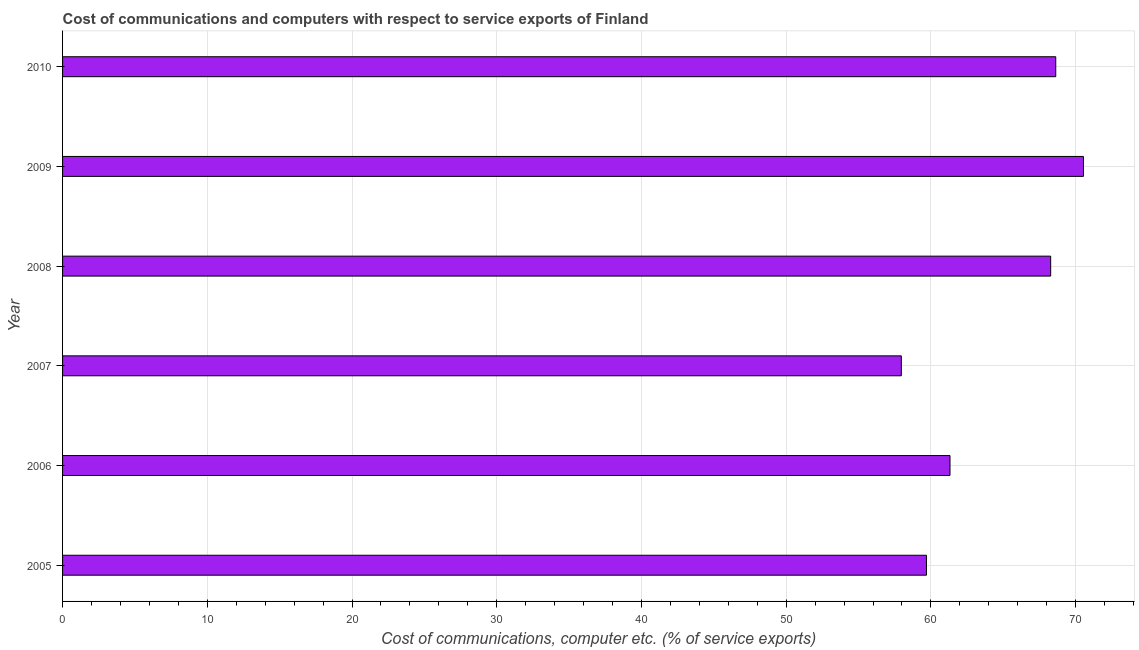Does the graph contain any zero values?
Ensure brevity in your answer.  No. What is the title of the graph?
Your answer should be very brief. Cost of communications and computers with respect to service exports of Finland. What is the label or title of the X-axis?
Make the answer very short. Cost of communications, computer etc. (% of service exports). What is the cost of communications and computer in 2009?
Keep it short and to the point. 70.54. Across all years, what is the maximum cost of communications and computer?
Offer a very short reply. 70.54. Across all years, what is the minimum cost of communications and computer?
Offer a very short reply. 57.95. In which year was the cost of communications and computer maximum?
Provide a succinct answer. 2009. In which year was the cost of communications and computer minimum?
Provide a succinct answer. 2007. What is the sum of the cost of communications and computer?
Provide a short and direct response. 386.4. What is the difference between the cost of communications and computer in 2007 and 2008?
Your answer should be very brief. -10.32. What is the average cost of communications and computer per year?
Ensure brevity in your answer.  64.4. What is the median cost of communications and computer?
Offer a very short reply. 64.8. Do a majority of the years between 2007 and 2005 (inclusive) have cost of communications and computer greater than 34 %?
Your response must be concise. Yes. What is the difference between the highest and the second highest cost of communications and computer?
Provide a succinct answer. 1.91. What is the difference between the highest and the lowest cost of communications and computer?
Provide a succinct answer. 12.58. In how many years, is the cost of communications and computer greater than the average cost of communications and computer taken over all years?
Offer a terse response. 3. How many bars are there?
Your response must be concise. 6. How many years are there in the graph?
Give a very brief answer. 6. What is the Cost of communications, computer etc. (% of service exports) in 2005?
Provide a succinct answer. 59.69. What is the Cost of communications, computer etc. (% of service exports) in 2006?
Your answer should be very brief. 61.32. What is the Cost of communications, computer etc. (% of service exports) of 2007?
Give a very brief answer. 57.95. What is the Cost of communications, computer etc. (% of service exports) in 2008?
Provide a succinct answer. 68.27. What is the Cost of communications, computer etc. (% of service exports) of 2009?
Your answer should be compact. 70.54. What is the Cost of communications, computer etc. (% of service exports) of 2010?
Keep it short and to the point. 68.62. What is the difference between the Cost of communications, computer etc. (% of service exports) in 2005 and 2006?
Provide a short and direct response. -1.63. What is the difference between the Cost of communications, computer etc. (% of service exports) in 2005 and 2007?
Ensure brevity in your answer.  1.74. What is the difference between the Cost of communications, computer etc. (% of service exports) in 2005 and 2008?
Give a very brief answer. -8.58. What is the difference between the Cost of communications, computer etc. (% of service exports) in 2005 and 2009?
Provide a short and direct response. -10.85. What is the difference between the Cost of communications, computer etc. (% of service exports) in 2005 and 2010?
Offer a very short reply. -8.93. What is the difference between the Cost of communications, computer etc. (% of service exports) in 2006 and 2007?
Provide a succinct answer. 3.36. What is the difference between the Cost of communications, computer etc. (% of service exports) in 2006 and 2008?
Your answer should be compact. -6.96. What is the difference between the Cost of communications, computer etc. (% of service exports) in 2006 and 2009?
Your response must be concise. -9.22. What is the difference between the Cost of communications, computer etc. (% of service exports) in 2006 and 2010?
Give a very brief answer. -7.31. What is the difference between the Cost of communications, computer etc. (% of service exports) in 2007 and 2008?
Your answer should be very brief. -10.32. What is the difference between the Cost of communications, computer etc. (% of service exports) in 2007 and 2009?
Keep it short and to the point. -12.58. What is the difference between the Cost of communications, computer etc. (% of service exports) in 2007 and 2010?
Your answer should be very brief. -10.67. What is the difference between the Cost of communications, computer etc. (% of service exports) in 2008 and 2009?
Your response must be concise. -2.26. What is the difference between the Cost of communications, computer etc. (% of service exports) in 2008 and 2010?
Keep it short and to the point. -0.35. What is the difference between the Cost of communications, computer etc. (% of service exports) in 2009 and 2010?
Offer a terse response. 1.91. What is the ratio of the Cost of communications, computer etc. (% of service exports) in 2005 to that in 2008?
Keep it short and to the point. 0.87. What is the ratio of the Cost of communications, computer etc. (% of service exports) in 2005 to that in 2009?
Provide a short and direct response. 0.85. What is the ratio of the Cost of communications, computer etc. (% of service exports) in 2005 to that in 2010?
Ensure brevity in your answer.  0.87. What is the ratio of the Cost of communications, computer etc. (% of service exports) in 2006 to that in 2007?
Give a very brief answer. 1.06. What is the ratio of the Cost of communications, computer etc. (% of service exports) in 2006 to that in 2008?
Your answer should be very brief. 0.9. What is the ratio of the Cost of communications, computer etc. (% of service exports) in 2006 to that in 2009?
Ensure brevity in your answer.  0.87. What is the ratio of the Cost of communications, computer etc. (% of service exports) in 2006 to that in 2010?
Ensure brevity in your answer.  0.89. What is the ratio of the Cost of communications, computer etc. (% of service exports) in 2007 to that in 2008?
Offer a terse response. 0.85. What is the ratio of the Cost of communications, computer etc. (% of service exports) in 2007 to that in 2009?
Keep it short and to the point. 0.82. What is the ratio of the Cost of communications, computer etc. (% of service exports) in 2007 to that in 2010?
Provide a succinct answer. 0.84. What is the ratio of the Cost of communications, computer etc. (% of service exports) in 2008 to that in 2010?
Provide a short and direct response. 0.99. What is the ratio of the Cost of communications, computer etc. (% of service exports) in 2009 to that in 2010?
Provide a succinct answer. 1.03. 